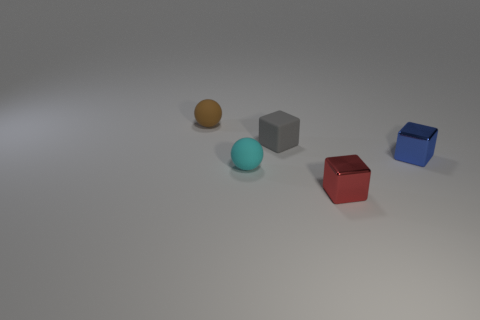What number of other objects are the same material as the tiny cyan thing?
Make the answer very short. 2. Do the object that is on the right side of the small red cube and the metallic object in front of the cyan ball have the same size?
Provide a succinct answer. Yes. What number of things are objects on the left side of the tiny cyan rubber object or things that are on the left side of the small red metallic thing?
Keep it short and to the point. 3. Is there anything else that has the same shape as the small blue thing?
Provide a succinct answer. Yes. Do the tiny thing on the right side of the small red shiny block and the matte ball behind the small blue metal object have the same color?
Offer a terse response. No. How many metallic objects are either small gray objects or tiny cyan cylinders?
Your answer should be compact. 0. Are there any other things that have the same size as the cyan rubber ball?
Your answer should be compact. Yes. The rubber object that is left of the ball that is in front of the tiny gray matte object is what shape?
Provide a succinct answer. Sphere. Is the material of the thing that is behind the gray object the same as the tiny cube left of the tiny red metallic block?
Offer a terse response. Yes. How many tiny red metal blocks are in front of the matte sphere in front of the small brown sphere?
Keep it short and to the point. 1. 